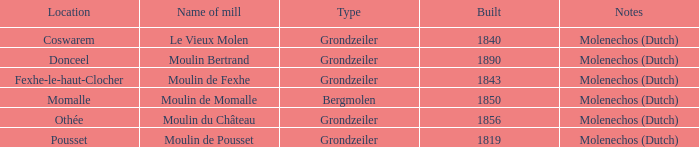Where is the moulin bertrand mill situated? Donceel. 